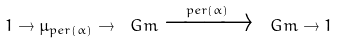Convert formula to latex. <formula><loc_0><loc_0><loc_500><loc_500>1 \rightarrow \mu _ { p e r ( \alpha ) } \rightarrow \ G m \xrightarrow { p e r ( \alpha ) } \ G m \rightarrow 1</formula> 